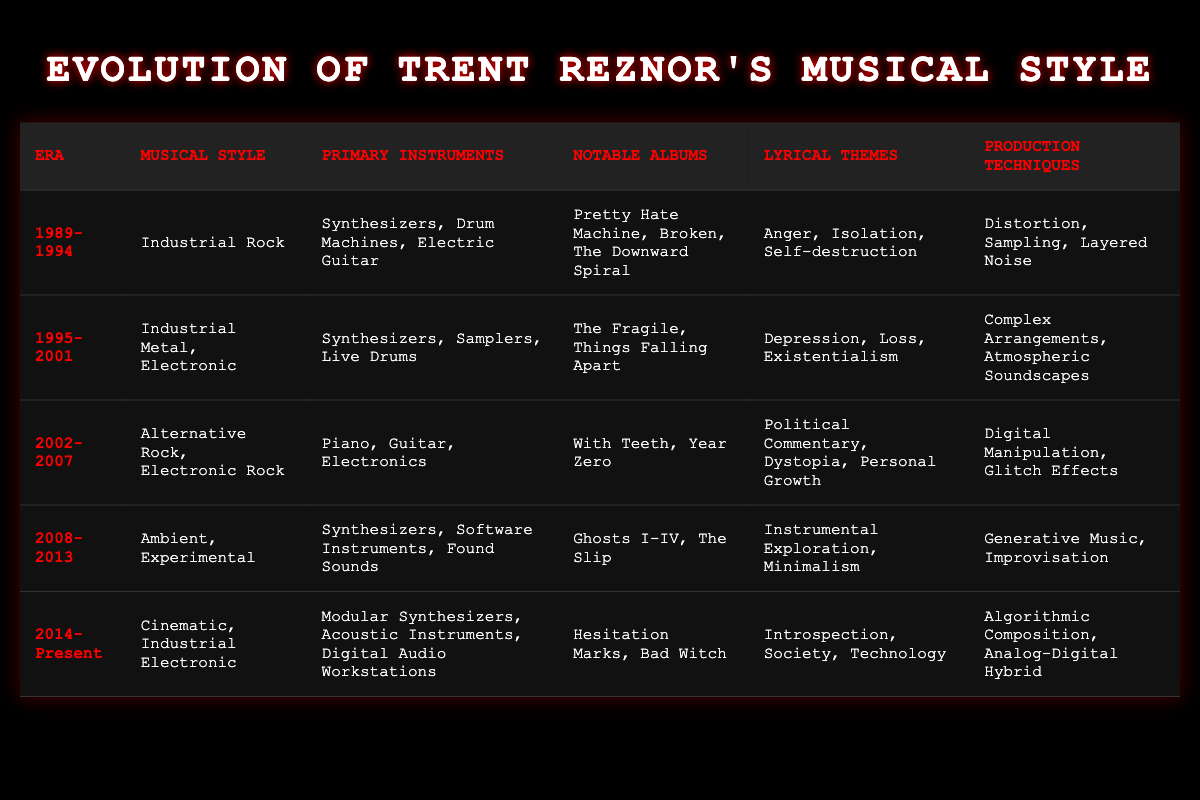What musical style was prominent in the era 1989-1994? According to the table, the musical style for the era 1989-1994 is indicated as Industrial Rock. This information is retrieved directly from the corresponding row relevant to that specific time period.
Answer: Industrial Rock Which notable albums were released during the era 1995-2001? The table lists the notable albums for the era 1995-2001 as The Fragile and Things Falling Apart. This can be found in the row that corresponds to that specific era.
Answer: The Fragile, Things Falling Apart Did Trent Reznor use acoustic instruments in the 2008-2013 era? To answer this, we need to refer to the primary instruments listed for the era 2008-2013, which states "Synthesizers, Software Instruments, Found Sounds." Since acoustic instruments are not included, the answer is no.
Answer: No In which era did the musical style transition to Cinematic and Industrial Electronic? The table shows that the transition to Cinematic and Industrial Electronic happened in the era 2014-Present. This can be identified by looking at the corresponding musical style for this time frame.
Answer: 2014-Present What are the primary instruments used in the era 2002-2007? The primary instruments listed in the table for the era 2002-2007 are Piano, Guitar, and Electronics. This information comes directly from the specific row related to that time frame.
Answer: Piano, Guitar, Electronics What is the difference in lyrical themes between the eras 1995-2001 and 2002-2007? The lyrical themes for 1995-2001 are Depression, Loss, and Existentialism, while for 2002-2007 they are Political Commentary, Dystopia, and Personal Growth. The answer involves listing both themes and highlighting the distinct focuses of each era.
Answer: Different themes focus on emotional struggles versus political and social commentary How many primary instruments are listed for the 2014-Present era compared to the 1989-1994 era? The era 2014-Present lists three primary instruments: Modular Synthesizers, Acoustic Instruments, Digital Audio Workstations. In contrast, the era 1989-1994 lists three as well: Synthesizers, Drum Machines, Electric Guitar. The count shows both eras have the same number of primary instruments.
Answer: Both eras have three primary instruments What production technique was exclusive to the 2008-2013 era? The table indicates that the production techniques for the 2008-2013 era include Generative Music and Improvisation, which aren't mentioned in other eras. Checking all other rows confirms this technique does not appear elsewhere.
Answer: Generative Music, Improvisation Was the theme of Introspection present in the 2002-2007 era? Referring to the lyrical themes listed for 2002-2007, they are focused on Political Commentary, Dystopia, and Personal Growth, which does not include Introspection. Hence, the answer is no.
Answer: No 